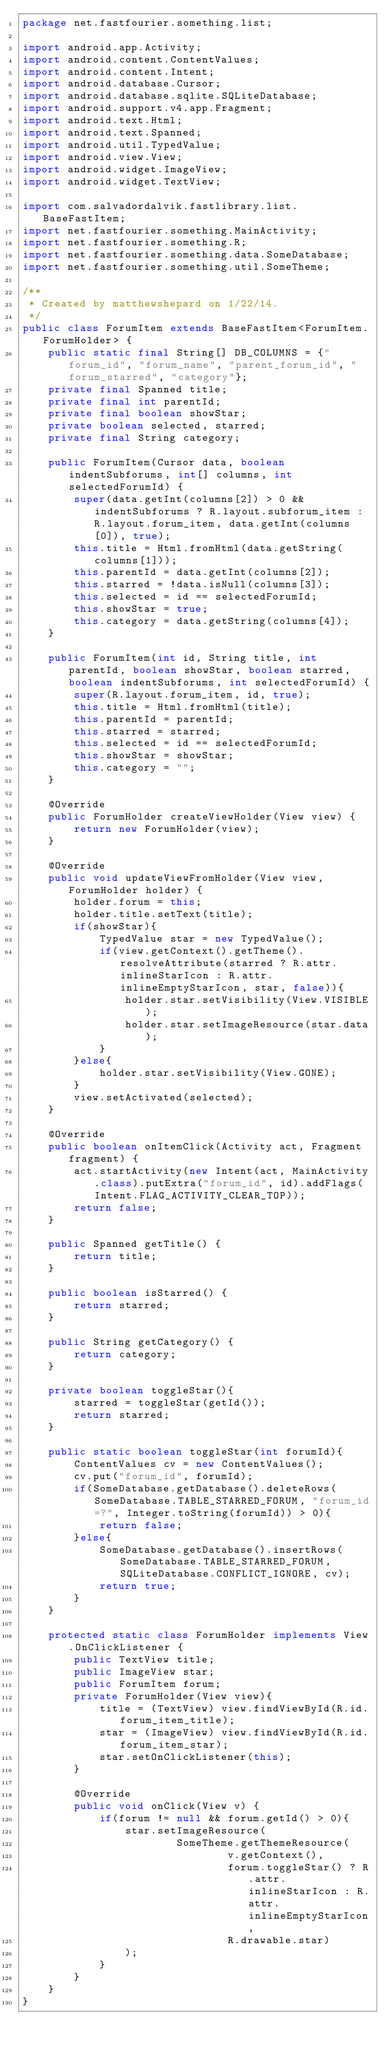Convert code to text. <code><loc_0><loc_0><loc_500><loc_500><_Java_>package net.fastfourier.something.list;

import android.app.Activity;
import android.content.ContentValues;
import android.content.Intent;
import android.database.Cursor;
import android.database.sqlite.SQLiteDatabase;
import android.support.v4.app.Fragment;
import android.text.Html;
import android.text.Spanned;
import android.util.TypedValue;
import android.view.View;
import android.widget.ImageView;
import android.widget.TextView;

import com.salvadordalvik.fastlibrary.list.BaseFastItem;
import net.fastfourier.something.MainActivity;
import net.fastfourier.something.R;
import net.fastfourier.something.data.SomeDatabase;
import net.fastfourier.something.util.SomeTheme;

/**
 * Created by matthewshepard on 1/22/14.
 */
public class ForumItem extends BaseFastItem<ForumItem.ForumHolder> {
    public static final String[] DB_COLUMNS = {"forum_id", "forum_name", "parent_forum_id", "forum_starred", "category"};
    private final Spanned title;
    private final int parentId;
    private final boolean showStar;
    private boolean selected, starred;
    private final String category;

    public ForumItem(Cursor data, boolean indentSubforums, int[] columns, int selectedForumId) {
        super(data.getInt(columns[2]) > 0 && indentSubforums ? R.layout.subforum_item : R.layout.forum_item, data.getInt(columns[0]), true);
        this.title = Html.fromHtml(data.getString(columns[1]));
        this.parentId = data.getInt(columns[2]);
        this.starred = !data.isNull(columns[3]);
        this.selected = id == selectedForumId;
        this.showStar = true;
        this.category = data.getString(columns[4]);
    }

    public ForumItem(int id, String title, int parentId, boolean showStar, boolean starred, boolean indentSubforums, int selectedForumId) {
        super(R.layout.forum_item, id, true);
        this.title = Html.fromHtml(title);
        this.parentId = parentId;
        this.starred = starred;
        this.selected = id == selectedForumId;
        this.showStar = showStar;
        this.category = "";
    }

    @Override
    public ForumHolder createViewHolder(View view) {
        return new ForumHolder(view);
    }

    @Override
    public void updateViewFromHolder(View view, ForumHolder holder) {
        holder.forum = this;
        holder.title.setText(title);
        if(showStar){
            TypedValue star = new TypedValue();
            if(view.getContext().getTheme().resolveAttribute(starred ? R.attr.inlineStarIcon : R.attr.inlineEmptyStarIcon, star, false)){
                holder.star.setVisibility(View.VISIBLE);
                holder.star.setImageResource(star.data);
            }
        }else{
            holder.star.setVisibility(View.GONE);
        }
        view.setActivated(selected);
    }

    @Override
    public boolean onItemClick(Activity act, Fragment fragment) {
        act.startActivity(new Intent(act, MainActivity.class).putExtra("forum_id", id).addFlags(Intent.FLAG_ACTIVITY_CLEAR_TOP));
        return false;
    }

    public Spanned getTitle() {
        return title;
    }

    public boolean isStarred() {
        return starred;
    }

    public String getCategory() {
        return category;
    }

    private boolean toggleStar(){
        starred = toggleStar(getId());
        return starred;
    }

    public static boolean toggleStar(int forumId){
        ContentValues cv = new ContentValues();
        cv.put("forum_id", forumId);
        if(SomeDatabase.getDatabase().deleteRows(SomeDatabase.TABLE_STARRED_FORUM, "forum_id=?", Integer.toString(forumId)) > 0){
            return false;
        }else{
            SomeDatabase.getDatabase().insertRows(SomeDatabase.TABLE_STARRED_FORUM, SQLiteDatabase.CONFLICT_IGNORE, cv);
            return true;
        }
    }

    protected static class ForumHolder implements View.OnClickListener {
        public TextView title;
        public ImageView star;
        public ForumItem forum;
        private ForumHolder(View view){
            title = (TextView) view.findViewById(R.id.forum_item_title);
            star = (ImageView) view.findViewById(R.id.forum_item_star);
            star.setOnClickListener(this);
        }

        @Override
        public void onClick(View v) {
            if(forum != null && forum.getId() > 0){
                star.setImageResource(
                        SomeTheme.getThemeResource(
                                v.getContext(),
                                forum.toggleStar() ? R.attr.inlineStarIcon : R.attr.inlineEmptyStarIcon,
                                R.drawable.star)
                );
            }
        }
    }
}
</code> 